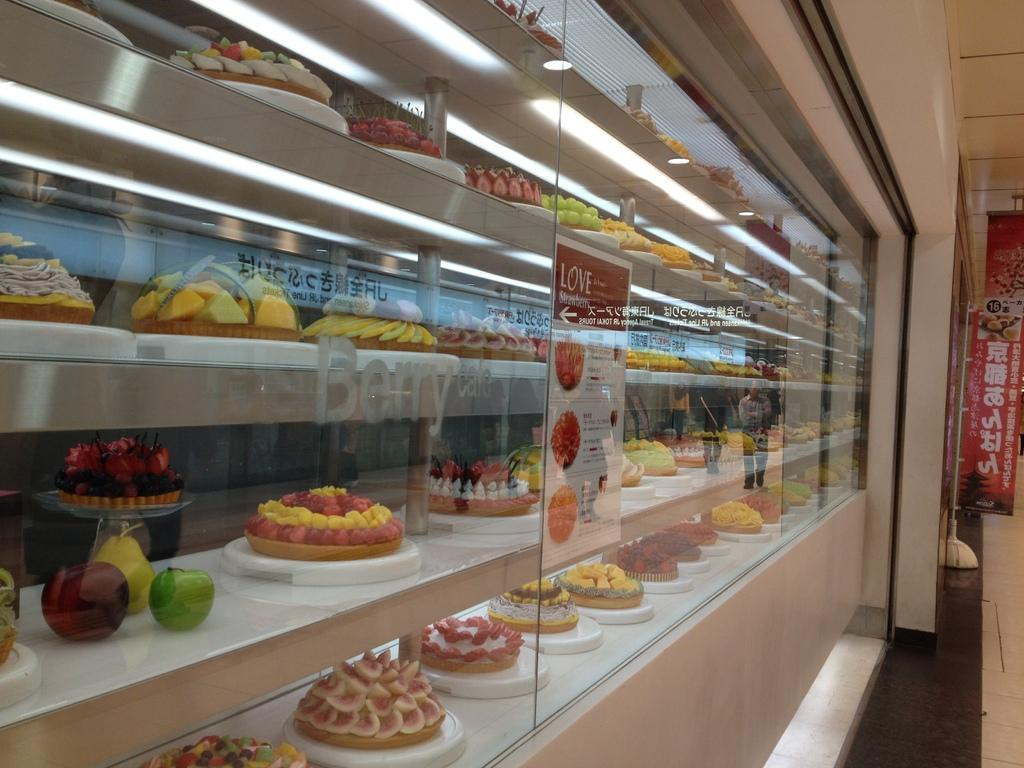<image>
Render a clear and concise summary of the photo. A bakery case displays a number of different Berry flavored products. 